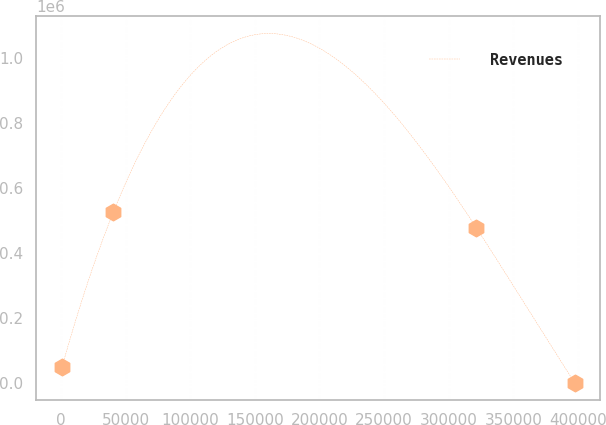<chart> <loc_0><loc_0><loc_500><loc_500><line_chart><ecel><fcel>Revenues<nl><fcel>786.06<fcel>49193.6<nl><fcel>40449.7<fcel>525250<nl><fcel>321534<fcel>476156<nl><fcel>397423<fcel>99.96<nl></chart> 